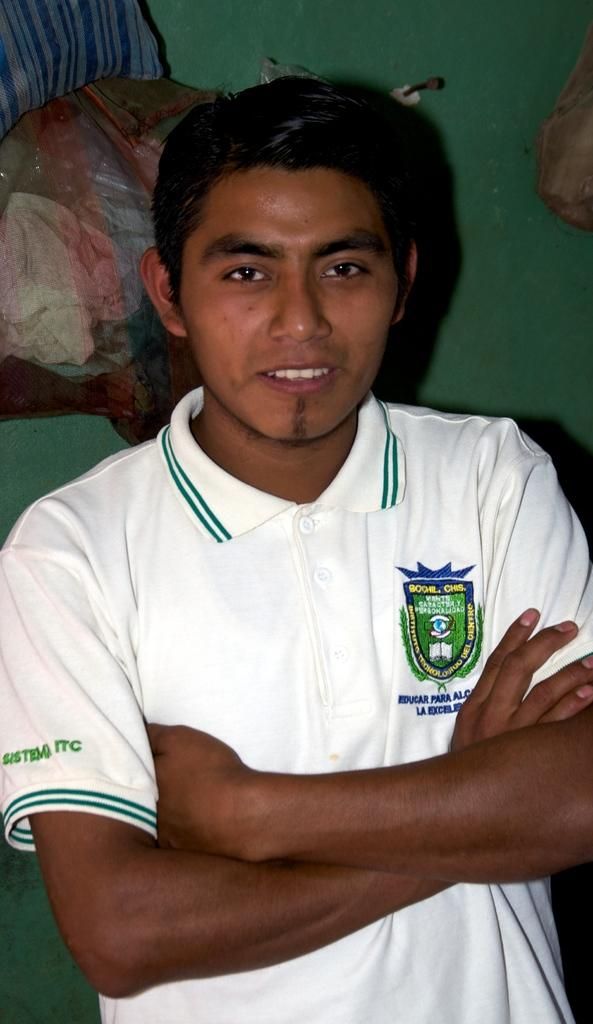What is the main subject of the image? There is a person standing in the image. What is the person wearing? The person is wearing a white shirt. What color is the background of the image? The background of the image is green. What type of drug can be seen in the person's hand in the image? There is no drug present in the image; the person is not holding anything in their hand. 